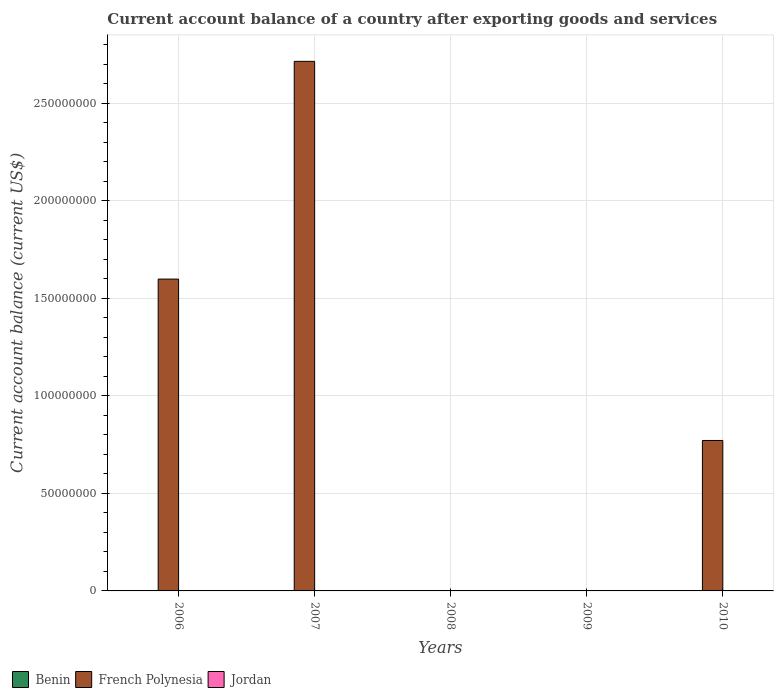How many different coloured bars are there?
Offer a very short reply. 1. Are the number of bars on each tick of the X-axis equal?
Make the answer very short. No. How many bars are there on the 4th tick from the right?
Your response must be concise. 1. In how many cases, is the number of bars for a given year not equal to the number of legend labels?
Make the answer very short. 5. Across all years, what is the maximum account balance in French Polynesia?
Your response must be concise. 2.71e+08. In which year was the account balance in French Polynesia maximum?
Provide a short and direct response. 2007. What is the difference between the account balance in French Polynesia in 2007 and the account balance in Jordan in 2008?
Give a very brief answer. 2.71e+08. What is the average account balance in French Polynesia per year?
Ensure brevity in your answer.  1.02e+08. In how many years, is the account balance in Benin greater than 10000000 US$?
Your response must be concise. 0. What is the ratio of the account balance in French Polynesia in 2006 to that in 2010?
Give a very brief answer. 2.07. What is the difference between the highest and the second highest account balance in French Polynesia?
Your response must be concise. 1.12e+08. What is the difference between the highest and the lowest account balance in French Polynesia?
Offer a very short reply. 2.71e+08. How many bars are there?
Give a very brief answer. 3. How many years are there in the graph?
Make the answer very short. 5. Does the graph contain grids?
Your answer should be very brief. Yes. Where does the legend appear in the graph?
Provide a short and direct response. Bottom left. How are the legend labels stacked?
Provide a short and direct response. Horizontal. What is the title of the graph?
Provide a succinct answer. Current account balance of a country after exporting goods and services. Does "Sri Lanka" appear as one of the legend labels in the graph?
Keep it short and to the point. No. What is the label or title of the Y-axis?
Make the answer very short. Current account balance (current US$). What is the Current account balance (current US$) in Benin in 2006?
Keep it short and to the point. 0. What is the Current account balance (current US$) in French Polynesia in 2006?
Your response must be concise. 1.60e+08. What is the Current account balance (current US$) in French Polynesia in 2007?
Your answer should be compact. 2.71e+08. What is the Current account balance (current US$) of Jordan in 2007?
Your answer should be compact. 0. What is the Current account balance (current US$) of Jordan in 2008?
Your answer should be compact. 0. What is the Current account balance (current US$) in French Polynesia in 2009?
Ensure brevity in your answer.  0. What is the Current account balance (current US$) of Jordan in 2009?
Your answer should be compact. 0. What is the Current account balance (current US$) of French Polynesia in 2010?
Your answer should be very brief. 7.71e+07. Across all years, what is the maximum Current account balance (current US$) in French Polynesia?
Keep it short and to the point. 2.71e+08. Across all years, what is the minimum Current account balance (current US$) in French Polynesia?
Offer a terse response. 0. What is the total Current account balance (current US$) in Benin in the graph?
Your answer should be very brief. 0. What is the total Current account balance (current US$) in French Polynesia in the graph?
Keep it short and to the point. 5.08e+08. What is the difference between the Current account balance (current US$) in French Polynesia in 2006 and that in 2007?
Provide a short and direct response. -1.12e+08. What is the difference between the Current account balance (current US$) of French Polynesia in 2006 and that in 2010?
Make the answer very short. 8.27e+07. What is the difference between the Current account balance (current US$) in French Polynesia in 2007 and that in 2010?
Your response must be concise. 1.94e+08. What is the average Current account balance (current US$) in Benin per year?
Give a very brief answer. 0. What is the average Current account balance (current US$) of French Polynesia per year?
Your answer should be very brief. 1.02e+08. What is the average Current account balance (current US$) in Jordan per year?
Provide a succinct answer. 0. What is the ratio of the Current account balance (current US$) in French Polynesia in 2006 to that in 2007?
Offer a very short reply. 0.59. What is the ratio of the Current account balance (current US$) of French Polynesia in 2006 to that in 2010?
Ensure brevity in your answer.  2.07. What is the ratio of the Current account balance (current US$) of French Polynesia in 2007 to that in 2010?
Offer a terse response. 3.52. What is the difference between the highest and the second highest Current account balance (current US$) in French Polynesia?
Your answer should be compact. 1.12e+08. What is the difference between the highest and the lowest Current account balance (current US$) of French Polynesia?
Provide a short and direct response. 2.71e+08. 